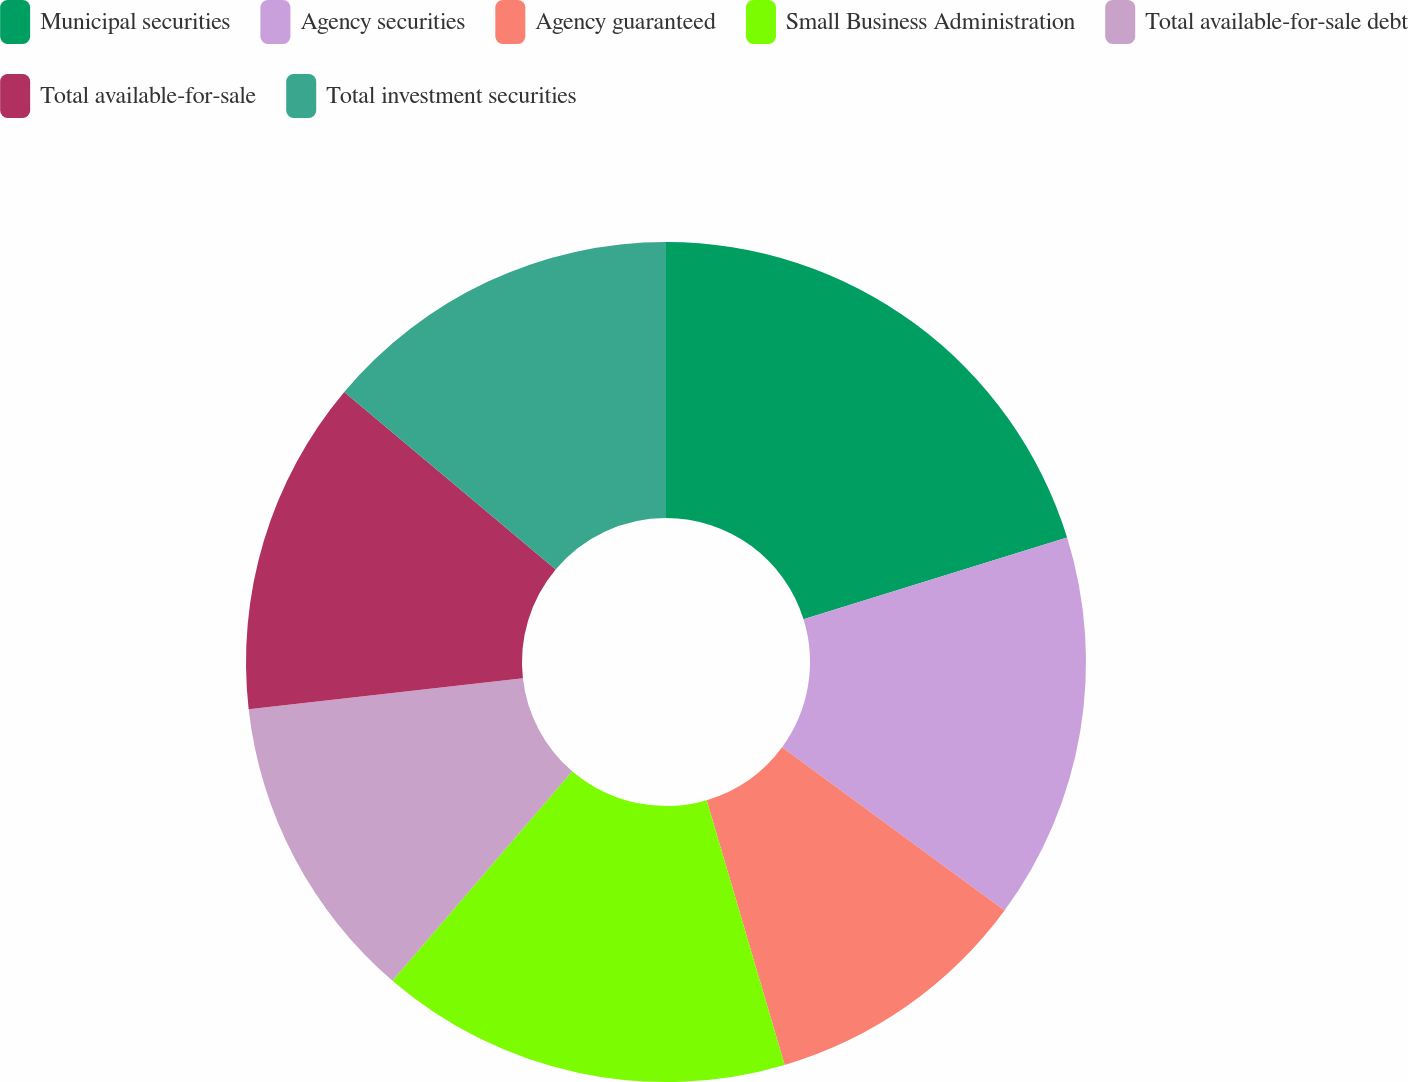Convert chart. <chart><loc_0><loc_0><loc_500><loc_500><pie_chart><fcel>Municipal securities<fcel>Agency securities<fcel>Agency guaranteed<fcel>Small Business Administration<fcel>Total available-for-sale debt<fcel>Total available-for-sale<fcel>Total investment securities<nl><fcel>20.21%<fcel>14.87%<fcel>10.36%<fcel>15.85%<fcel>11.92%<fcel>12.9%<fcel>13.89%<nl></chart> 